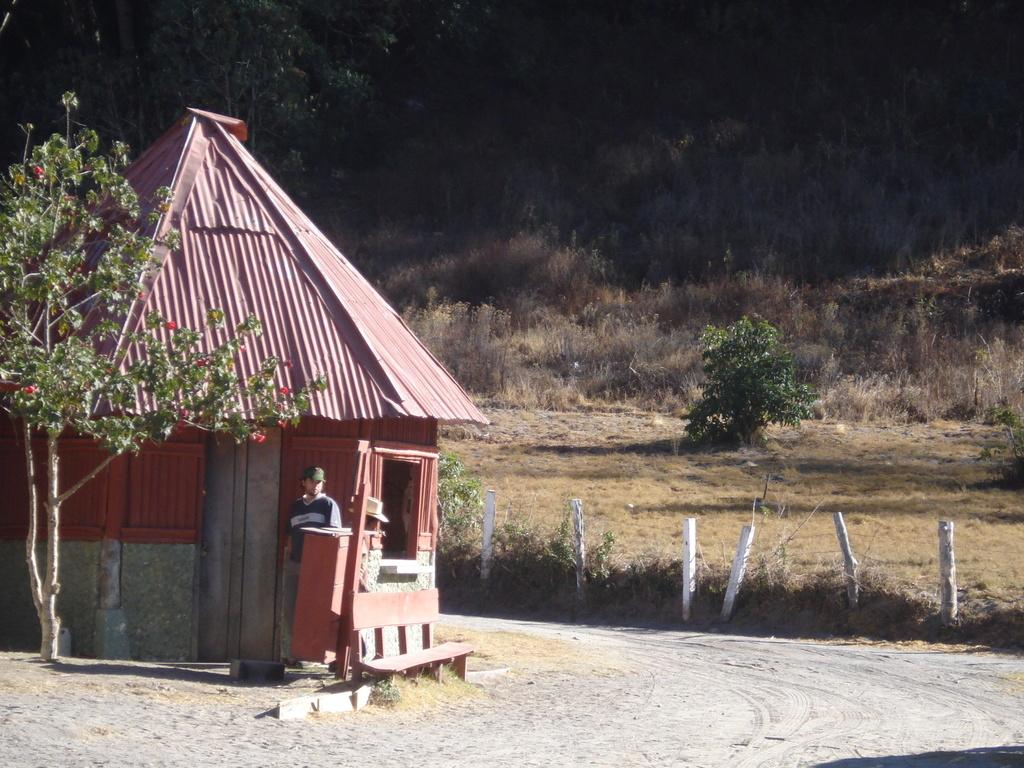What is the main subject in the image? There is a person standing in the image. What can be seen in the background of the image? There is a shed and trees with green leaves in the background of the image. Are there any specific colors or features of the flowers in the image? Yes, there are flowers with red petals in the image. What type of camera can be seen in the image? There is no camera present in the image. How many men are visible in the image? The image only features one person, so there is only one man visible. 